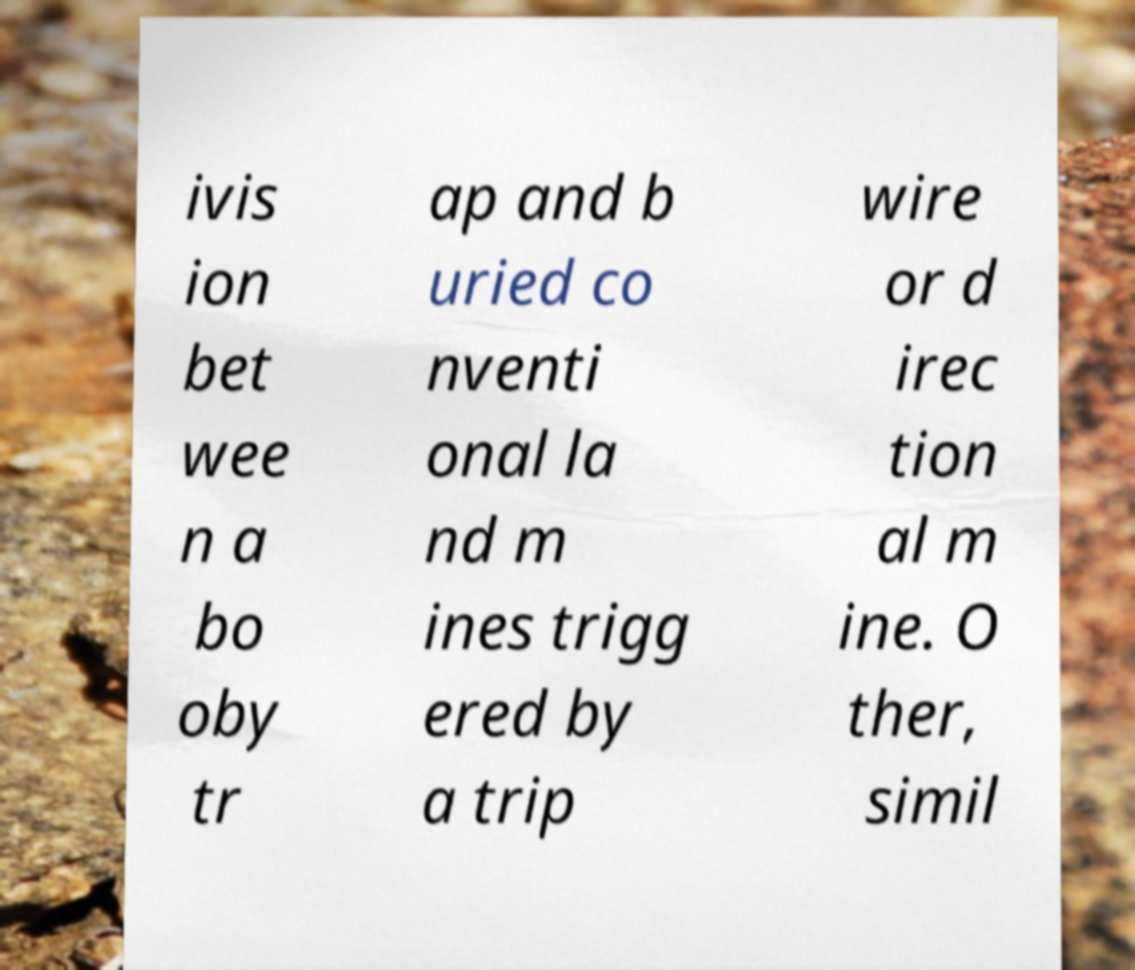Can you read and provide the text displayed in the image?This photo seems to have some interesting text. Can you extract and type it out for me? ivis ion bet wee n a bo oby tr ap and b uried co nventi onal la nd m ines trigg ered by a trip wire or d irec tion al m ine. O ther, simil 